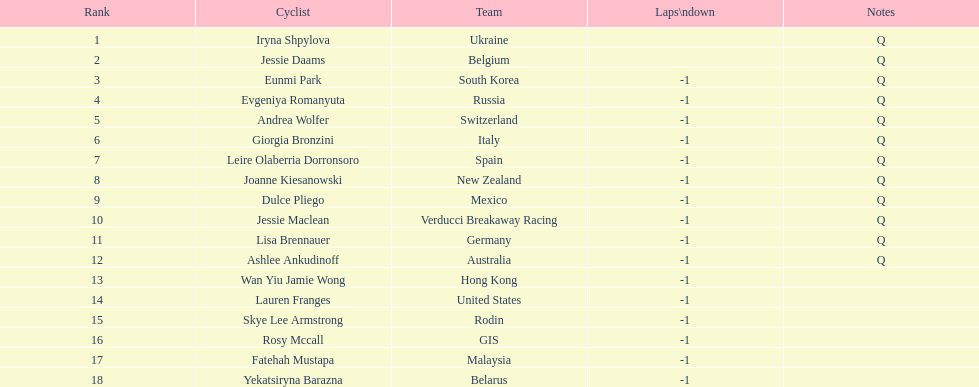How many cyclist are not listed with a country team? 3. 